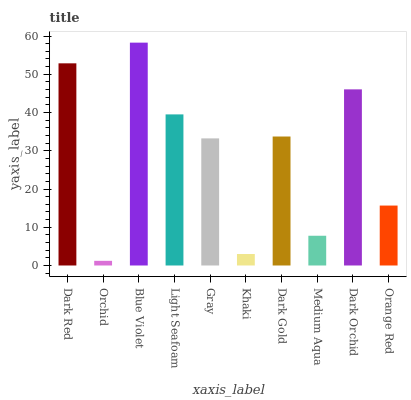Is Blue Violet the minimum?
Answer yes or no. No. Is Orchid the maximum?
Answer yes or no. No. Is Blue Violet greater than Orchid?
Answer yes or no. Yes. Is Orchid less than Blue Violet?
Answer yes or no. Yes. Is Orchid greater than Blue Violet?
Answer yes or no. No. Is Blue Violet less than Orchid?
Answer yes or no. No. Is Dark Gold the high median?
Answer yes or no. Yes. Is Gray the low median?
Answer yes or no. Yes. Is Orange Red the high median?
Answer yes or no. No. Is Orchid the low median?
Answer yes or no. No. 